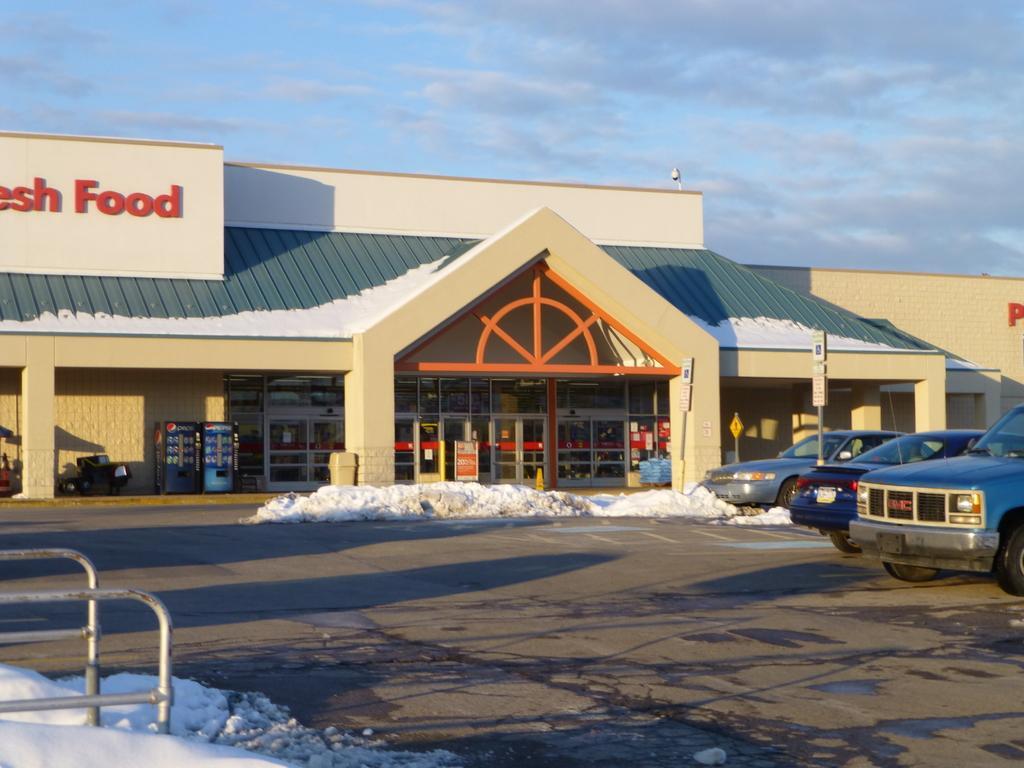Can you describe this image briefly? Vehicles are on the road. In-front of this store there are boards, bin, snow and signboards. This is hoarding. Sky is cloudy. Here we can see rods. 